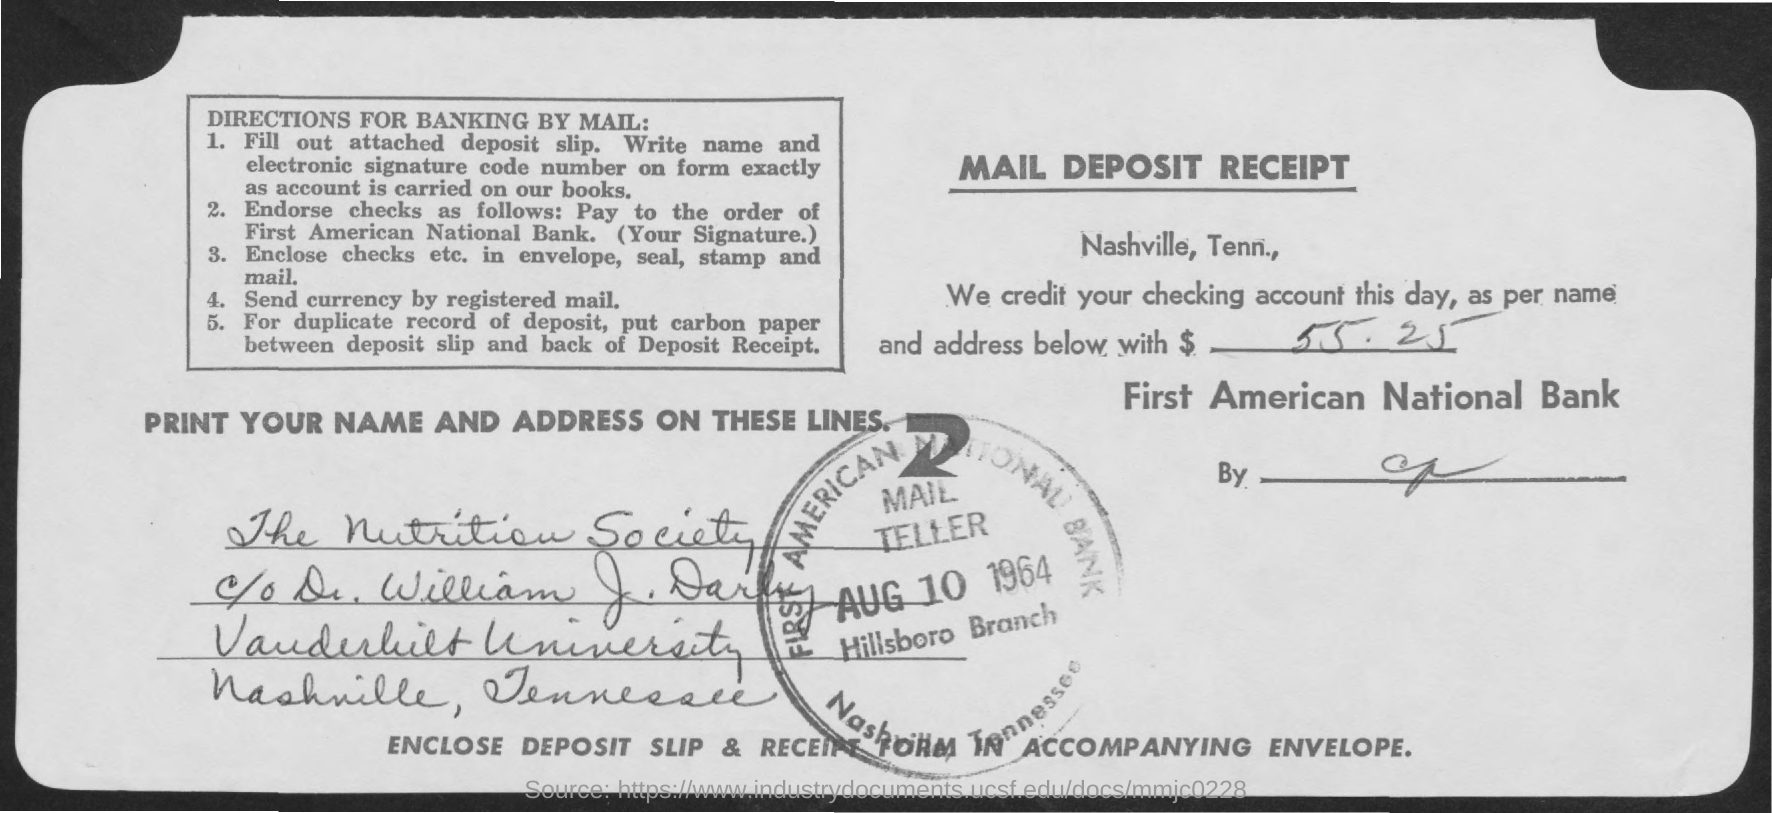Mention a couple of crucial points in this snapshot. First American National Bank has credited the amount. The amount credited, as mentioned in the email deposit receipt, is 55.25... The amount has been credited to the account of the Nutrition Society. 